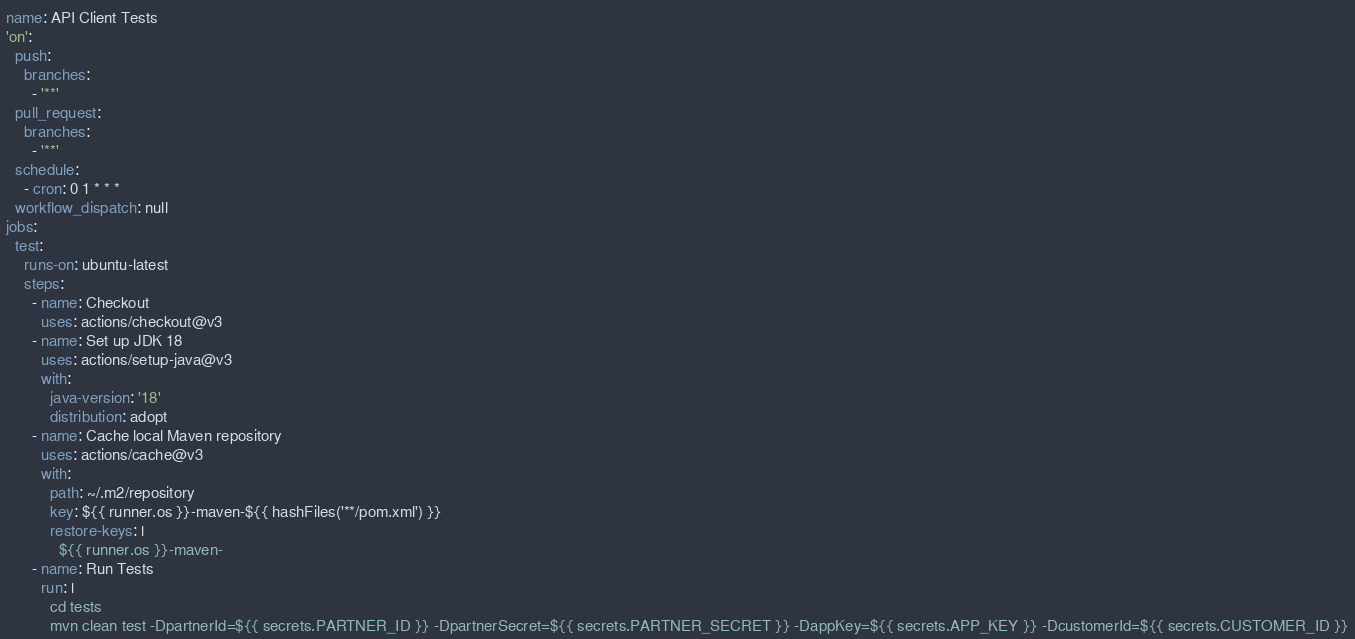Convert code to text. <code><loc_0><loc_0><loc_500><loc_500><_YAML_>name: API Client Tests
'on':
  push:
    branches:
      - '**'
  pull_request:
    branches:
      - '**'
  schedule:
    - cron: 0 1 * * *
  workflow_dispatch: null
jobs:
  test:
    runs-on: ubuntu-latest
    steps:
      - name: Checkout
        uses: actions/checkout@v3
      - name: Set up JDK 18
        uses: actions/setup-java@v3
        with:
          java-version: '18'
          distribution: adopt
      - name: Cache local Maven repository
        uses: actions/cache@v3
        with:
          path: ~/.m2/repository
          key: ${{ runner.os }}-maven-${{ hashFiles('**/pom.xml') }}
          restore-keys: |
            ${{ runner.os }}-maven-
      - name: Run Tests
        run: |
          cd tests
          mvn clean test -DpartnerId=${{ secrets.PARTNER_ID }} -DpartnerSecret=${{ secrets.PARTNER_SECRET }} -DappKey=${{ secrets.APP_KEY }} -DcustomerId=${{ secrets.CUSTOMER_ID }}</code> 